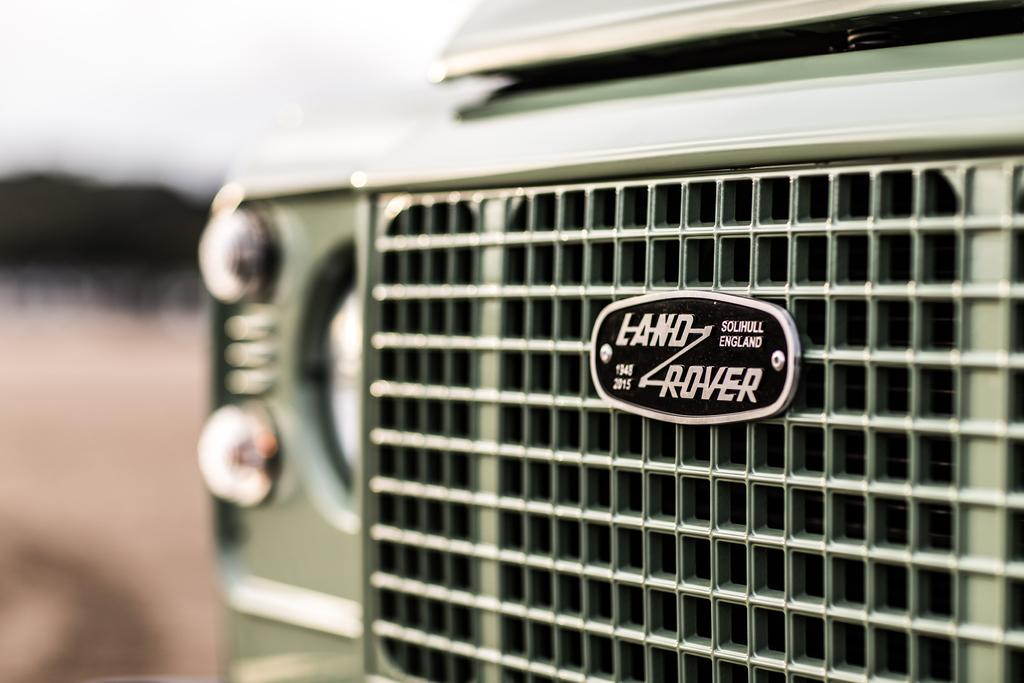What is the main subject of the image? The main subject of the image is a land rover vehicle. Can you describe the background of the image? The background of the image is blurred. What type of distribution system is visible in the image? There is no distribution system present in the image; it is a zoomed in picture of a land rover vehicle. How many screws can be seen on the land rover in the image? The image does not provide enough detail to count the number of screws on the land rover. 